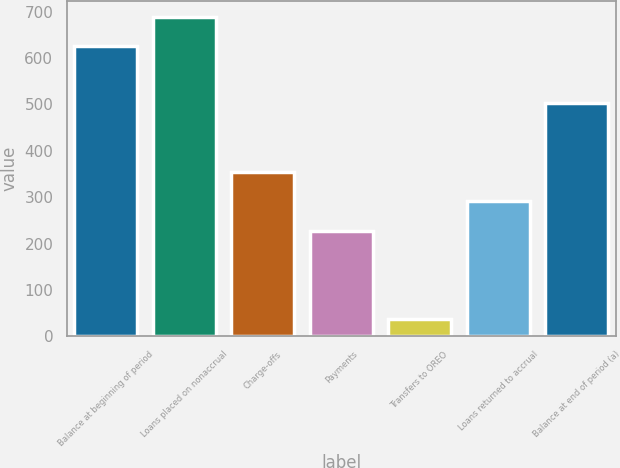Convert chart. <chart><loc_0><loc_0><loc_500><loc_500><bar_chart><fcel>Balance at beginning of period<fcel>Loans placed on nonaccrual<fcel>Charge-offs<fcel>Payments<fcel>Transfers to OREO<fcel>Loans returned to accrual<fcel>Balance at end of period (a)<nl><fcel>625<fcel>689.2<fcel>355.4<fcel>227<fcel>37<fcel>291.2<fcel>503<nl></chart> 